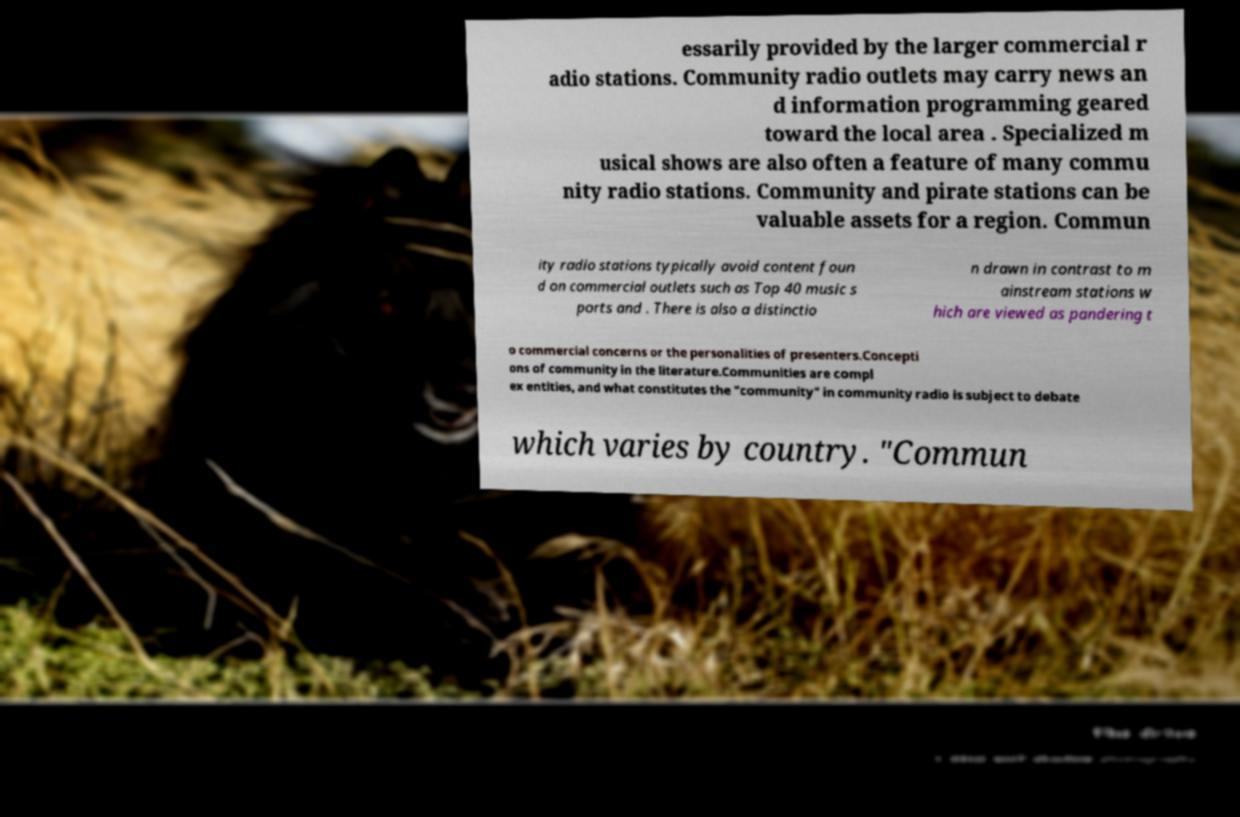Please read and relay the text visible in this image. What does it say? essarily provided by the larger commercial r adio stations. Community radio outlets may carry news an d information programming geared toward the local area . Specialized m usical shows are also often a feature of many commu nity radio stations. Community and pirate stations can be valuable assets for a region. Commun ity radio stations typically avoid content foun d on commercial outlets such as Top 40 music s ports and . There is also a distinctio n drawn in contrast to m ainstream stations w hich are viewed as pandering t o commercial concerns or the personalities of presenters.Concepti ons of community in the literature.Communities are compl ex entities, and what constitutes the "community" in community radio is subject to debate which varies by country. "Commun 